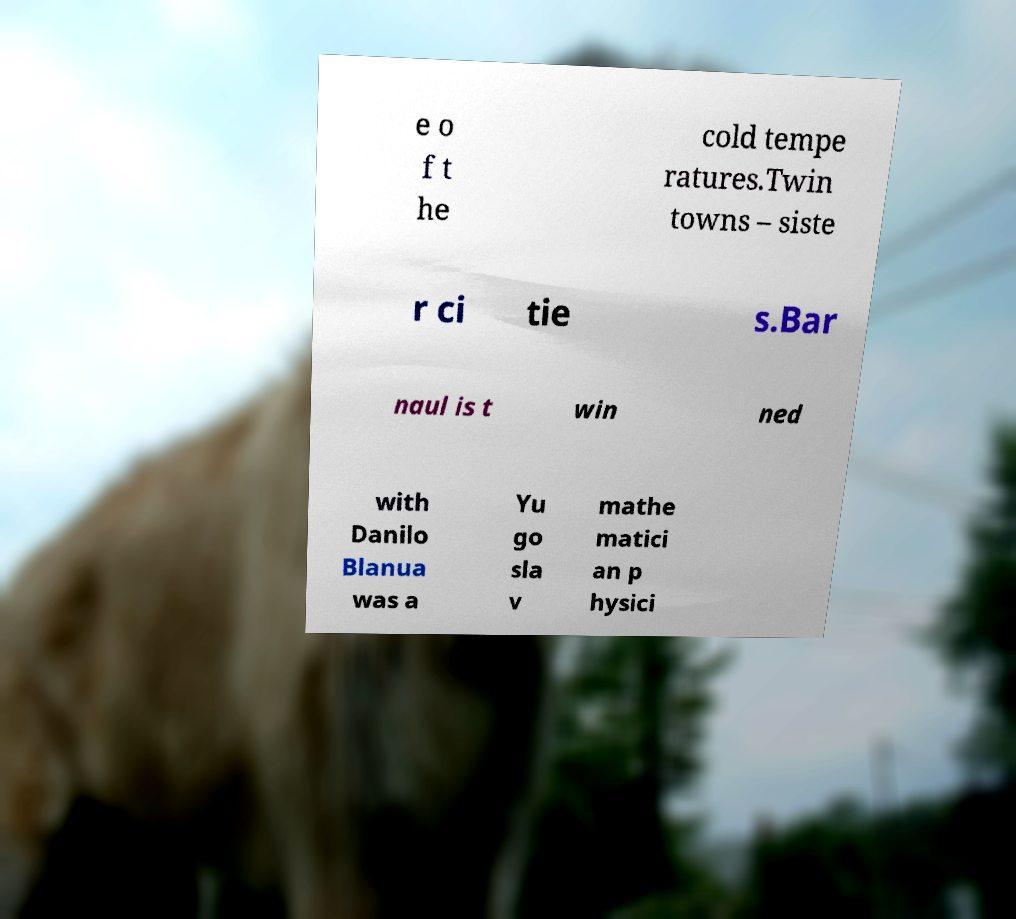Can you accurately transcribe the text from the provided image for me? e o f t he cold tempe ratures.Twin towns – siste r ci tie s.Bar naul is t win ned with Danilo Blanua was a Yu go sla v mathe matici an p hysici 